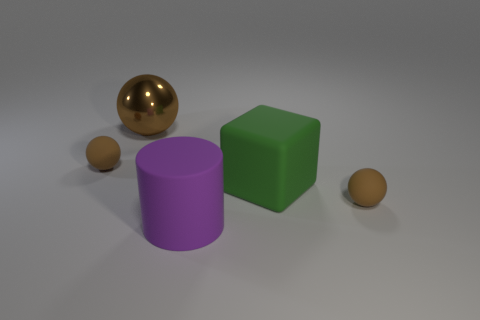Subtract all brown spheres. How many were subtracted if there are1brown spheres left? 2 Subtract all small brown spheres. How many spheres are left? 1 Subtract all balls. How many objects are left? 2 Add 1 big shiny blocks. How many objects exist? 6 Subtract all large green things. Subtract all large purple objects. How many objects are left? 3 Add 5 large brown spheres. How many large brown spheres are left? 6 Add 2 big things. How many big things exist? 5 Subtract 2 brown spheres. How many objects are left? 3 Subtract 3 balls. How many balls are left? 0 Subtract all purple cubes. Subtract all green spheres. How many cubes are left? 1 